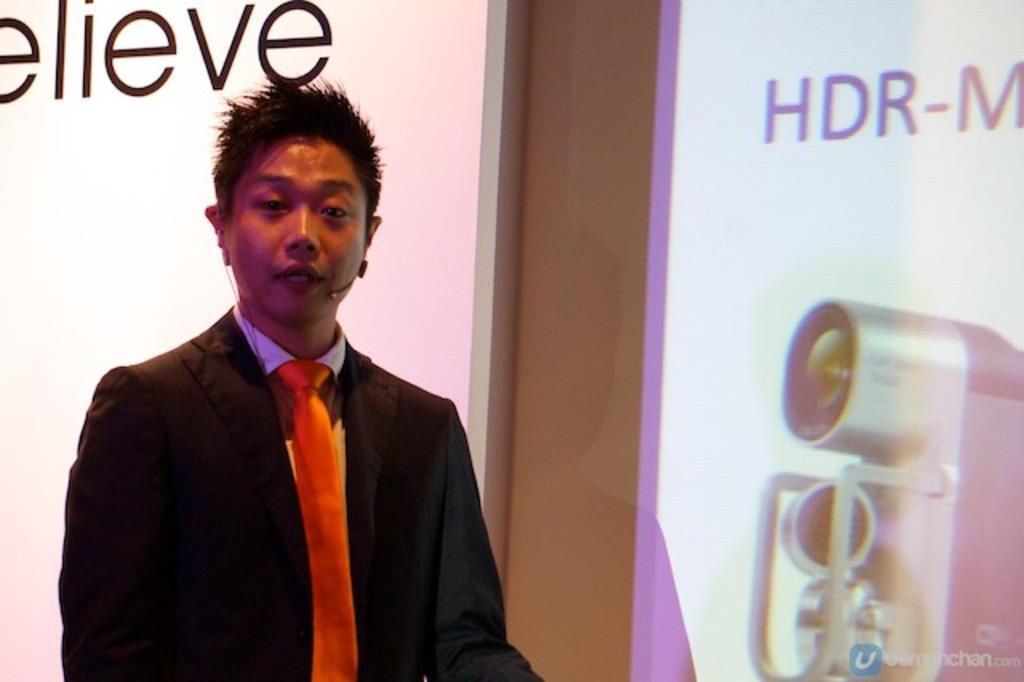Who is the main subject in the picture? There is a man in the picture. What is the man doing in the image? The man is giving a speech. What can be seen on the right side of the picture? There is a projector screen on the right side of the picture. What type of net is being used to catch fish in the image? There is no net or fish present in the image; it features a man giving a speech with a projector screen on the right side. 